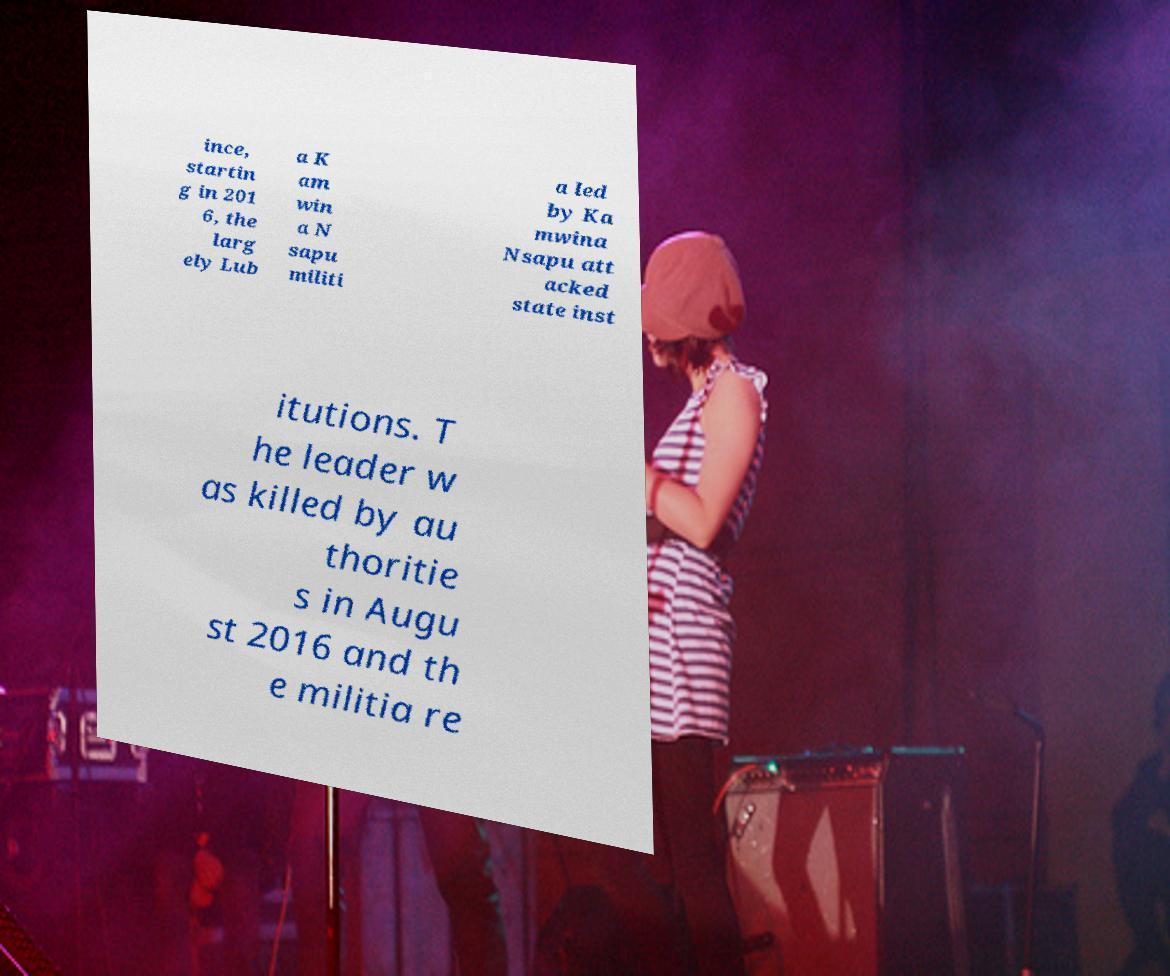Could you extract and type out the text from this image? ince, startin g in 201 6, the larg ely Lub a K am win a N sapu militi a led by Ka mwina Nsapu att acked state inst itutions. T he leader w as killed by au thoritie s in Augu st 2016 and th e militia re 